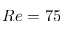<formula> <loc_0><loc_0><loc_500><loc_500>R e = 7 5</formula> 